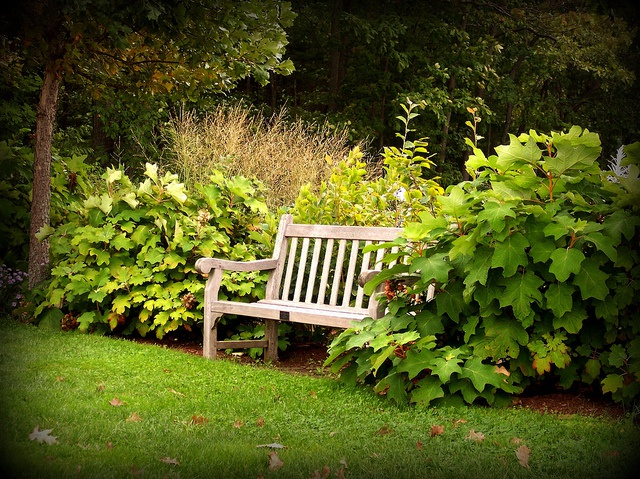Describe the objects in this image and their specific colors. I can see a bench in black, ivory, olive, and tan tones in this image. 